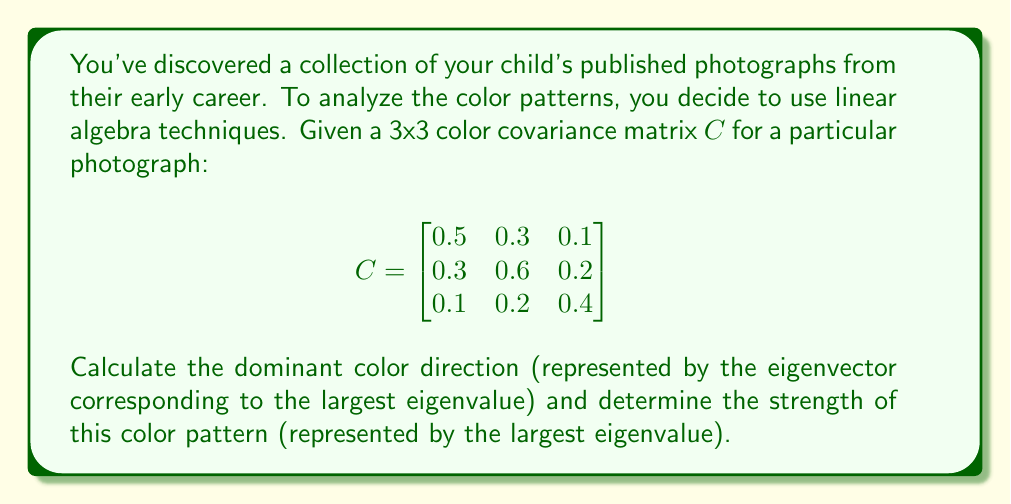Show me your answer to this math problem. 1. To find the eigenvalues, we need to solve the characteristic equation:
   $\det(C - \lambda I) = 0$

2. Expand the determinant:
   $$\begin{vmatrix}
   0.5-\lambda & 0.3 & 0.1 \\
   0.3 & 0.6-\lambda & 0.2 \\
   0.1 & 0.2 & 0.4-\lambda
   \end{vmatrix} = 0$$

3. Solve the resulting cubic equation:
   $-\lambda^3 + 1.5\lambda^2 - 0.71\lambda + 0.104 = 0$

4. The roots of this equation are the eigenvalues. Using a calculator or computer algebra system, we find:
   $\lambda_1 \approx 0.9539$, $\lambda_2 \approx 0.3746$, $\lambda_3 \approx 0.1715$

5. The largest eigenvalue is $\lambda_1 \approx 0.9539$, which represents the strength of the dominant color pattern.

6. To find the corresponding eigenvector, we solve $(C - \lambda_1 I)v = 0$:

   $$\begin{bmatrix}
   -0.4539 & 0.3 & 0.1 \\
   0.3 & -0.3539 & 0.2 \\
   0.1 & 0.2 & -0.5539
   \end{bmatrix} \begin{bmatrix} v_1 \\ v_2 \\ v_3 \end{bmatrix} = \begin{bmatrix} 0 \\ 0 \\ 0 \end{bmatrix}$$

7. Solving this system (using Gaussian elimination or a computer algebra system), we get:
   $v \approx (0.6325, 0.6742, 0.3807)$

8. Normalizing this vector to unit length:
   $v_{norm} \approx (0.6325, 0.6742, 0.3807) / \sqrt{0.6325^2 + 0.6742^2 + 0.3807^2} \approx (0.6156, 0.6562, 0.3706)$

This normalized eigenvector represents the dominant color direction in RGB space.
Answer: Dominant color direction: $(0.6156, 0.6562, 0.3706)$; Strength: $0.9539$ 